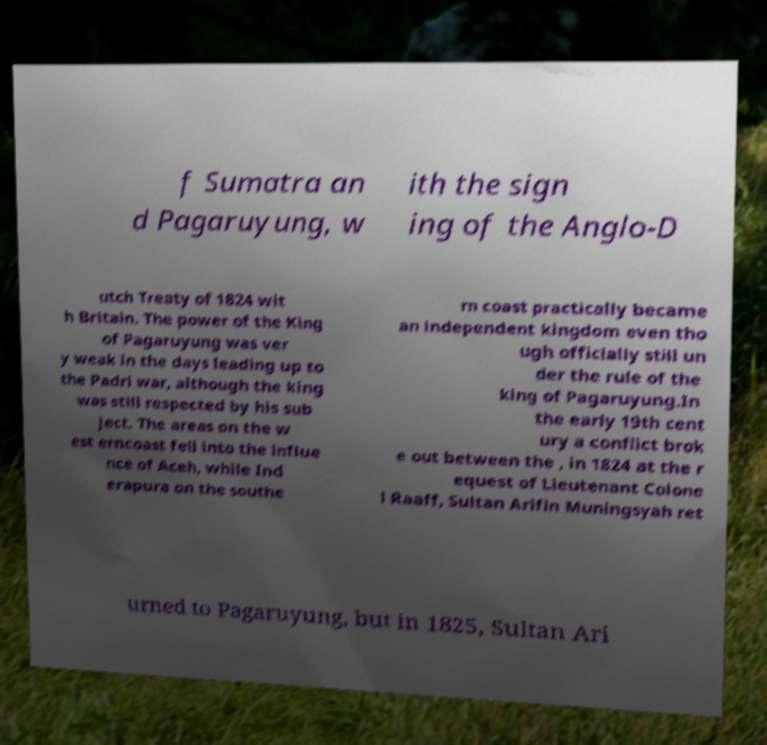Please read and relay the text visible in this image. What does it say? f Sumatra an d Pagaruyung, w ith the sign ing of the Anglo-D utch Treaty of 1824 wit h Britain. The power of the King of Pagaruyung was ver y weak in the days leading up to the Padri war, although the king was still respected by his sub ject. The areas on the w est erncoast fell into the influe nce of Aceh, while Ind erapura on the southe rn coast practically became an independent kingdom even tho ugh officially still un der the rule of the king of Pagaruyung.In the early 19th cent ury a conflict brok e out between the , in 1824 at the r equest of Lieutenant Colone l Raaff, Sultan Arifin Muningsyah ret urned to Pagaruyung, but in 1825, Sultan Ari 